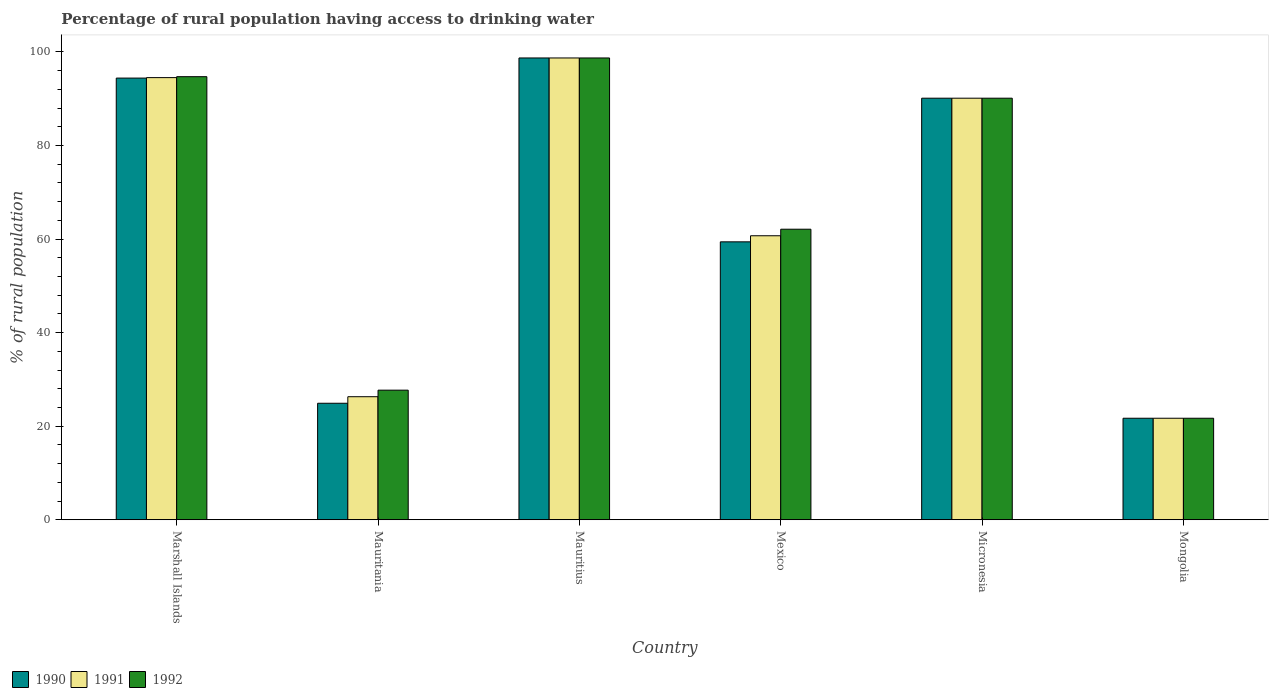How many different coloured bars are there?
Ensure brevity in your answer.  3. How many groups of bars are there?
Provide a short and direct response. 6. Are the number of bars per tick equal to the number of legend labels?
Offer a very short reply. Yes. What is the label of the 1st group of bars from the left?
Make the answer very short. Marshall Islands. In how many cases, is the number of bars for a given country not equal to the number of legend labels?
Your answer should be compact. 0. What is the percentage of rural population having access to drinking water in 1991 in Mongolia?
Give a very brief answer. 21.7. Across all countries, what is the maximum percentage of rural population having access to drinking water in 1991?
Make the answer very short. 98.7. Across all countries, what is the minimum percentage of rural population having access to drinking water in 1992?
Provide a short and direct response. 21.7. In which country was the percentage of rural population having access to drinking water in 1991 maximum?
Make the answer very short. Mauritius. In which country was the percentage of rural population having access to drinking water in 1991 minimum?
Offer a terse response. Mongolia. What is the total percentage of rural population having access to drinking water in 1990 in the graph?
Your answer should be very brief. 389.2. What is the difference between the percentage of rural population having access to drinking water in 1990 in Micronesia and that in Mongolia?
Ensure brevity in your answer.  68.4. What is the difference between the percentage of rural population having access to drinking water in 1992 in Mauritania and the percentage of rural population having access to drinking water in 1990 in Mexico?
Your answer should be compact. -31.7. What is the average percentage of rural population having access to drinking water in 1992 per country?
Make the answer very short. 65.83. What is the difference between the percentage of rural population having access to drinking water of/in 1991 and percentage of rural population having access to drinking water of/in 1990 in Mexico?
Make the answer very short. 1.3. What is the ratio of the percentage of rural population having access to drinking water in 1992 in Mauritania to that in Micronesia?
Keep it short and to the point. 0.31. Is the percentage of rural population having access to drinking water in 1990 in Micronesia less than that in Mongolia?
Provide a succinct answer. No. What is the difference between the highest and the second highest percentage of rural population having access to drinking water in 1992?
Keep it short and to the point. 8.6. How many bars are there?
Provide a short and direct response. 18. What is the difference between two consecutive major ticks on the Y-axis?
Your answer should be compact. 20. Are the values on the major ticks of Y-axis written in scientific E-notation?
Keep it short and to the point. No. How are the legend labels stacked?
Your answer should be compact. Horizontal. What is the title of the graph?
Give a very brief answer. Percentage of rural population having access to drinking water. What is the label or title of the Y-axis?
Provide a short and direct response. % of rural population. What is the % of rural population in 1990 in Marshall Islands?
Ensure brevity in your answer.  94.4. What is the % of rural population of 1991 in Marshall Islands?
Offer a terse response. 94.5. What is the % of rural population of 1992 in Marshall Islands?
Give a very brief answer. 94.7. What is the % of rural population of 1990 in Mauritania?
Give a very brief answer. 24.9. What is the % of rural population in 1991 in Mauritania?
Offer a very short reply. 26.3. What is the % of rural population of 1992 in Mauritania?
Keep it short and to the point. 27.7. What is the % of rural population in 1990 in Mauritius?
Offer a very short reply. 98.7. What is the % of rural population of 1991 in Mauritius?
Your answer should be compact. 98.7. What is the % of rural population of 1992 in Mauritius?
Ensure brevity in your answer.  98.7. What is the % of rural population in 1990 in Mexico?
Provide a succinct answer. 59.4. What is the % of rural population in 1991 in Mexico?
Offer a very short reply. 60.7. What is the % of rural population of 1992 in Mexico?
Ensure brevity in your answer.  62.1. What is the % of rural population of 1990 in Micronesia?
Ensure brevity in your answer.  90.1. What is the % of rural population of 1991 in Micronesia?
Your response must be concise. 90.1. What is the % of rural population of 1992 in Micronesia?
Provide a short and direct response. 90.1. What is the % of rural population in 1990 in Mongolia?
Offer a very short reply. 21.7. What is the % of rural population of 1991 in Mongolia?
Keep it short and to the point. 21.7. What is the % of rural population of 1992 in Mongolia?
Your response must be concise. 21.7. Across all countries, what is the maximum % of rural population in 1990?
Offer a terse response. 98.7. Across all countries, what is the maximum % of rural population of 1991?
Your answer should be compact. 98.7. Across all countries, what is the maximum % of rural population in 1992?
Your response must be concise. 98.7. Across all countries, what is the minimum % of rural population of 1990?
Ensure brevity in your answer.  21.7. Across all countries, what is the minimum % of rural population in 1991?
Ensure brevity in your answer.  21.7. Across all countries, what is the minimum % of rural population in 1992?
Provide a succinct answer. 21.7. What is the total % of rural population in 1990 in the graph?
Ensure brevity in your answer.  389.2. What is the total % of rural population of 1991 in the graph?
Offer a terse response. 392. What is the total % of rural population of 1992 in the graph?
Make the answer very short. 395. What is the difference between the % of rural population of 1990 in Marshall Islands and that in Mauritania?
Your response must be concise. 69.5. What is the difference between the % of rural population of 1991 in Marshall Islands and that in Mauritania?
Provide a short and direct response. 68.2. What is the difference between the % of rural population of 1992 in Marshall Islands and that in Mauritania?
Your answer should be very brief. 67. What is the difference between the % of rural population of 1991 in Marshall Islands and that in Mauritius?
Give a very brief answer. -4.2. What is the difference between the % of rural population of 1992 in Marshall Islands and that in Mauritius?
Offer a very short reply. -4. What is the difference between the % of rural population of 1990 in Marshall Islands and that in Mexico?
Your answer should be compact. 35. What is the difference between the % of rural population in 1991 in Marshall Islands and that in Mexico?
Ensure brevity in your answer.  33.8. What is the difference between the % of rural population in 1992 in Marshall Islands and that in Mexico?
Your answer should be compact. 32.6. What is the difference between the % of rural population in 1990 in Marshall Islands and that in Micronesia?
Provide a succinct answer. 4.3. What is the difference between the % of rural population in 1991 in Marshall Islands and that in Micronesia?
Your response must be concise. 4.4. What is the difference between the % of rural population in 1992 in Marshall Islands and that in Micronesia?
Offer a terse response. 4.6. What is the difference between the % of rural population of 1990 in Marshall Islands and that in Mongolia?
Give a very brief answer. 72.7. What is the difference between the % of rural population in 1991 in Marshall Islands and that in Mongolia?
Your answer should be compact. 72.8. What is the difference between the % of rural population in 1992 in Marshall Islands and that in Mongolia?
Provide a short and direct response. 73. What is the difference between the % of rural population of 1990 in Mauritania and that in Mauritius?
Your answer should be very brief. -73.8. What is the difference between the % of rural population of 1991 in Mauritania and that in Mauritius?
Your answer should be very brief. -72.4. What is the difference between the % of rural population in 1992 in Mauritania and that in Mauritius?
Your answer should be very brief. -71. What is the difference between the % of rural population of 1990 in Mauritania and that in Mexico?
Keep it short and to the point. -34.5. What is the difference between the % of rural population of 1991 in Mauritania and that in Mexico?
Make the answer very short. -34.4. What is the difference between the % of rural population of 1992 in Mauritania and that in Mexico?
Ensure brevity in your answer.  -34.4. What is the difference between the % of rural population in 1990 in Mauritania and that in Micronesia?
Give a very brief answer. -65.2. What is the difference between the % of rural population of 1991 in Mauritania and that in Micronesia?
Keep it short and to the point. -63.8. What is the difference between the % of rural population in 1992 in Mauritania and that in Micronesia?
Ensure brevity in your answer.  -62.4. What is the difference between the % of rural population in 1991 in Mauritania and that in Mongolia?
Provide a short and direct response. 4.6. What is the difference between the % of rural population in 1990 in Mauritius and that in Mexico?
Your answer should be compact. 39.3. What is the difference between the % of rural population in 1991 in Mauritius and that in Mexico?
Your answer should be compact. 38. What is the difference between the % of rural population in 1992 in Mauritius and that in Mexico?
Your answer should be very brief. 36.6. What is the difference between the % of rural population of 1990 in Mexico and that in Micronesia?
Your answer should be compact. -30.7. What is the difference between the % of rural population in 1991 in Mexico and that in Micronesia?
Give a very brief answer. -29.4. What is the difference between the % of rural population in 1992 in Mexico and that in Micronesia?
Your answer should be compact. -28. What is the difference between the % of rural population of 1990 in Mexico and that in Mongolia?
Your answer should be compact. 37.7. What is the difference between the % of rural population of 1991 in Mexico and that in Mongolia?
Provide a succinct answer. 39. What is the difference between the % of rural population in 1992 in Mexico and that in Mongolia?
Provide a short and direct response. 40.4. What is the difference between the % of rural population of 1990 in Micronesia and that in Mongolia?
Ensure brevity in your answer.  68.4. What is the difference between the % of rural population of 1991 in Micronesia and that in Mongolia?
Your response must be concise. 68.4. What is the difference between the % of rural population in 1992 in Micronesia and that in Mongolia?
Your answer should be very brief. 68.4. What is the difference between the % of rural population of 1990 in Marshall Islands and the % of rural population of 1991 in Mauritania?
Make the answer very short. 68.1. What is the difference between the % of rural population of 1990 in Marshall Islands and the % of rural population of 1992 in Mauritania?
Offer a terse response. 66.7. What is the difference between the % of rural population of 1991 in Marshall Islands and the % of rural population of 1992 in Mauritania?
Give a very brief answer. 66.8. What is the difference between the % of rural population of 1990 in Marshall Islands and the % of rural population of 1991 in Mexico?
Give a very brief answer. 33.7. What is the difference between the % of rural population in 1990 in Marshall Islands and the % of rural population in 1992 in Mexico?
Make the answer very short. 32.3. What is the difference between the % of rural population in 1991 in Marshall Islands and the % of rural population in 1992 in Mexico?
Give a very brief answer. 32.4. What is the difference between the % of rural population in 1990 in Marshall Islands and the % of rural population in 1991 in Micronesia?
Give a very brief answer. 4.3. What is the difference between the % of rural population of 1990 in Marshall Islands and the % of rural population of 1991 in Mongolia?
Provide a short and direct response. 72.7. What is the difference between the % of rural population in 1990 in Marshall Islands and the % of rural population in 1992 in Mongolia?
Ensure brevity in your answer.  72.7. What is the difference between the % of rural population in 1991 in Marshall Islands and the % of rural population in 1992 in Mongolia?
Your answer should be compact. 72.8. What is the difference between the % of rural population of 1990 in Mauritania and the % of rural population of 1991 in Mauritius?
Offer a terse response. -73.8. What is the difference between the % of rural population of 1990 in Mauritania and the % of rural population of 1992 in Mauritius?
Ensure brevity in your answer.  -73.8. What is the difference between the % of rural population of 1991 in Mauritania and the % of rural population of 1992 in Mauritius?
Make the answer very short. -72.4. What is the difference between the % of rural population of 1990 in Mauritania and the % of rural population of 1991 in Mexico?
Provide a short and direct response. -35.8. What is the difference between the % of rural population of 1990 in Mauritania and the % of rural population of 1992 in Mexico?
Your answer should be compact. -37.2. What is the difference between the % of rural population of 1991 in Mauritania and the % of rural population of 1992 in Mexico?
Give a very brief answer. -35.8. What is the difference between the % of rural population in 1990 in Mauritania and the % of rural population in 1991 in Micronesia?
Your answer should be very brief. -65.2. What is the difference between the % of rural population of 1990 in Mauritania and the % of rural population of 1992 in Micronesia?
Give a very brief answer. -65.2. What is the difference between the % of rural population in 1991 in Mauritania and the % of rural population in 1992 in Micronesia?
Provide a short and direct response. -63.8. What is the difference between the % of rural population of 1990 in Mauritania and the % of rural population of 1992 in Mongolia?
Make the answer very short. 3.2. What is the difference between the % of rural population in 1991 in Mauritania and the % of rural population in 1992 in Mongolia?
Your response must be concise. 4.6. What is the difference between the % of rural population of 1990 in Mauritius and the % of rural population of 1992 in Mexico?
Make the answer very short. 36.6. What is the difference between the % of rural population of 1991 in Mauritius and the % of rural population of 1992 in Mexico?
Your answer should be compact. 36.6. What is the difference between the % of rural population of 1990 in Mauritius and the % of rural population of 1992 in Micronesia?
Offer a very short reply. 8.6. What is the difference between the % of rural population of 1990 in Mauritius and the % of rural population of 1991 in Mongolia?
Give a very brief answer. 77. What is the difference between the % of rural population of 1990 in Mauritius and the % of rural population of 1992 in Mongolia?
Provide a short and direct response. 77. What is the difference between the % of rural population in 1990 in Mexico and the % of rural population in 1991 in Micronesia?
Make the answer very short. -30.7. What is the difference between the % of rural population of 1990 in Mexico and the % of rural population of 1992 in Micronesia?
Your answer should be compact. -30.7. What is the difference between the % of rural population of 1991 in Mexico and the % of rural population of 1992 in Micronesia?
Your answer should be compact. -29.4. What is the difference between the % of rural population in 1990 in Mexico and the % of rural population in 1991 in Mongolia?
Offer a terse response. 37.7. What is the difference between the % of rural population in 1990 in Mexico and the % of rural population in 1992 in Mongolia?
Make the answer very short. 37.7. What is the difference between the % of rural population in 1990 in Micronesia and the % of rural population in 1991 in Mongolia?
Your answer should be compact. 68.4. What is the difference between the % of rural population in 1990 in Micronesia and the % of rural population in 1992 in Mongolia?
Give a very brief answer. 68.4. What is the difference between the % of rural population of 1991 in Micronesia and the % of rural population of 1992 in Mongolia?
Offer a very short reply. 68.4. What is the average % of rural population in 1990 per country?
Offer a terse response. 64.87. What is the average % of rural population in 1991 per country?
Give a very brief answer. 65.33. What is the average % of rural population in 1992 per country?
Keep it short and to the point. 65.83. What is the difference between the % of rural population in 1990 and % of rural population in 1991 in Marshall Islands?
Give a very brief answer. -0.1. What is the difference between the % of rural population in 1990 and % of rural population in 1991 in Mauritania?
Make the answer very short. -1.4. What is the difference between the % of rural population of 1990 and % of rural population of 1992 in Mauritania?
Give a very brief answer. -2.8. What is the difference between the % of rural population of 1990 and % of rural population of 1991 in Mauritius?
Your response must be concise. 0. What is the difference between the % of rural population of 1990 and % of rural population of 1992 in Mauritius?
Keep it short and to the point. 0. What is the difference between the % of rural population in 1991 and % of rural population in 1992 in Mauritius?
Keep it short and to the point. 0. What is the difference between the % of rural population in 1990 and % of rural population in 1992 in Mexico?
Your response must be concise. -2.7. What is the difference between the % of rural population of 1991 and % of rural population of 1992 in Mexico?
Make the answer very short. -1.4. What is the difference between the % of rural population in 1990 and % of rural population in 1992 in Micronesia?
Offer a terse response. 0. What is the difference between the % of rural population in 1991 and % of rural population in 1992 in Micronesia?
Make the answer very short. 0. What is the difference between the % of rural population of 1990 and % of rural population of 1991 in Mongolia?
Make the answer very short. 0. What is the difference between the % of rural population of 1991 and % of rural population of 1992 in Mongolia?
Your answer should be very brief. 0. What is the ratio of the % of rural population of 1990 in Marshall Islands to that in Mauritania?
Offer a very short reply. 3.79. What is the ratio of the % of rural population of 1991 in Marshall Islands to that in Mauritania?
Ensure brevity in your answer.  3.59. What is the ratio of the % of rural population of 1992 in Marshall Islands to that in Mauritania?
Your answer should be compact. 3.42. What is the ratio of the % of rural population in 1990 in Marshall Islands to that in Mauritius?
Your response must be concise. 0.96. What is the ratio of the % of rural population of 1991 in Marshall Islands to that in Mauritius?
Keep it short and to the point. 0.96. What is the ratio of the % of rural population in 1992 in Marshall Islands to that in Mauritius?
Your answer should be very brief. 0.96. What is the ratio of the % of rural population in 1990 in Marshall Islands to that in Mexico?
Offer a very short reply. 1.59. What is the ratio of the % of rural population of 1991 in Marshall Islands to that in Mexico?
Offer a very short reply. 1.56. What is the ratio of the % of rural population of 1992 in Marshall Islands to that in Mexico?
Provide a succinct answer. 1.52. What is the ratio of the % of rural population in 1990 in Marshall Islands to that in Micronesia?
Offer a terse response. 1.05. What is the ratio of the % of rural population of 1991 in Marshall Islands to that in Micronesia?
Give a very brief answer. 1.05. What is the ratio of the % of rural population in 1992 in Marshall Islands to that in Micronesia?
Offer a very short reply. 1.05. What is the ratio of the % of rural population of 1990 in Marshall Islands to that in Mongolia?
Make the answer very short. 4.35. What is the ratio of the % of rural population in 1991 in Marshall Islands to that in Mongolia?
Make the answer very short. 4.35. What is the ratio of the % of rural population of 1992 in Marshall Islands to that in Mongolia?
Keep it short and to the point. 4.36. What is the ratio of the % of rural population of 1990 in Mauritania to that in Mauritius?
Provide a short and direct response. 0.25. What is the ratio of the % of rural population of 1991 in Mauritania to that in Mauritius?
Keep it short and to the point. 0.27. What is the ratio of the % of rural population in 1992 in Mauritania to that in Mauritius?
Ensure brevity in your answer.  0.28. What is the ratio of the % of rural population of 1990 in Mauritania to that in Mexico?
Offer a terse response. 0.42. What is the ratio of the % of rural population of 1991 in Mauritania to that in Mexico?
Offer a very short reply. 0.43. What is the ratio of the % of rural population in 1992 in Mauritania to that in Mexico?
Keep it short and to the point. 0.45. What is the ratio of the % of rural population in 1990 in Mauritania to that in Micronesia?
Offer a very short reply. 0.28. What is the ratio of the % of rural population in 1991 in Mauritania to that in Micronesia?
Make the answer very short. 0.29. What is the ratio of the % of rural population in 1992 in Mauritania to that in Micronesia?
Provide a short and direct response. 0.31. What is the ratio of the % of rural population in 1990 in Mauritania to that in Mongolia?
Your answer should be compact. 1.15. What is the ratio of the % of rural population of 1991 in Mauritania to that in Mongolia?
Offer a very short reply. 1.21. What is the ratio of the % of rural population in 1992 in Mauritania to that in Mongolia?
Provide a short and direct response. 1.28. What is the ratio of the % of rural population in 1990 in Mauritius to that in Mexico?
Provide a succinct answer. 1.66. What is the ratio of the % of rural population of 1991 in Mauritius to that in Mexico?
Keep it short and to the point. 1.63. What is the ratio of the % of rural population of 1992 in Mauritius to that in Mexico?
Ensure brevity in your answer.  1.59. What is the ratio of the % of rural population of 1990 in Mauritius to that in Micronesia?
Offer a very short reply. 1.1. What is the ratio of the % of rural population in 1991 in Mauritius to that in Micronesia?
Your answer should be compact. 1.1. What is the ratio of the % of rural population in 1992 in Mauritius to that in Micronesia?
Make the answer very short. 1.1. What is the ratio of the % of rural population in 1990 in Mauritius to that in Mongolia?
Your response must be concise. 4.55. What is the ratio of the % of rural population of 1991 in Mauritius to that in Mongolia?
Ensure brevity in your answer.  4.55. What is the ratio of the % of rural population in 1992 in Mauritius to that in Mongolia?
Your answer should be very brief. 4.55. What is the ratio of the % of rural population of 1990 in Mexico to that in Micronesia?
Offer a terse response. 0.66. What is the ratio of the % of rural population of 1991 in Mexico to that in Micronesia?
Offer a very short reply. 0.67. What is the ratio of the % of rural population of 1992 in Mexico to that in Micronesia?
Your answer should be compact. 0.69. What is the ratio of the % of rural population of 1990 in Mexico to that in Mongolia?
Your answer should be compact. 2.74. What is the ratio of the % of rural population of 1991 in Mexico to that in Mongolia?
Offer a terse response. 2.8. What is the ratio of the % of rural population of 1992 in Mexico to that in Mongolia?
Ensure brevity in your answer.  2.86. What is the ratio of the % of rural population of 1990 in Micronesia to that in Mongolia?
Offer a terse response. 4.15. What is the ratio of the % of rural population in 1991 in Micronesia to that in Mongolia?
Offer a terse response. 4.15. What is the ratio of the % of rural population of 1992 in Micronesia to that in Mongolia?
Provide a succinct answer. 4.15. What is the difference between the highest and the lowest % of rural population of 1990?
Give a very brief answer. 77. 